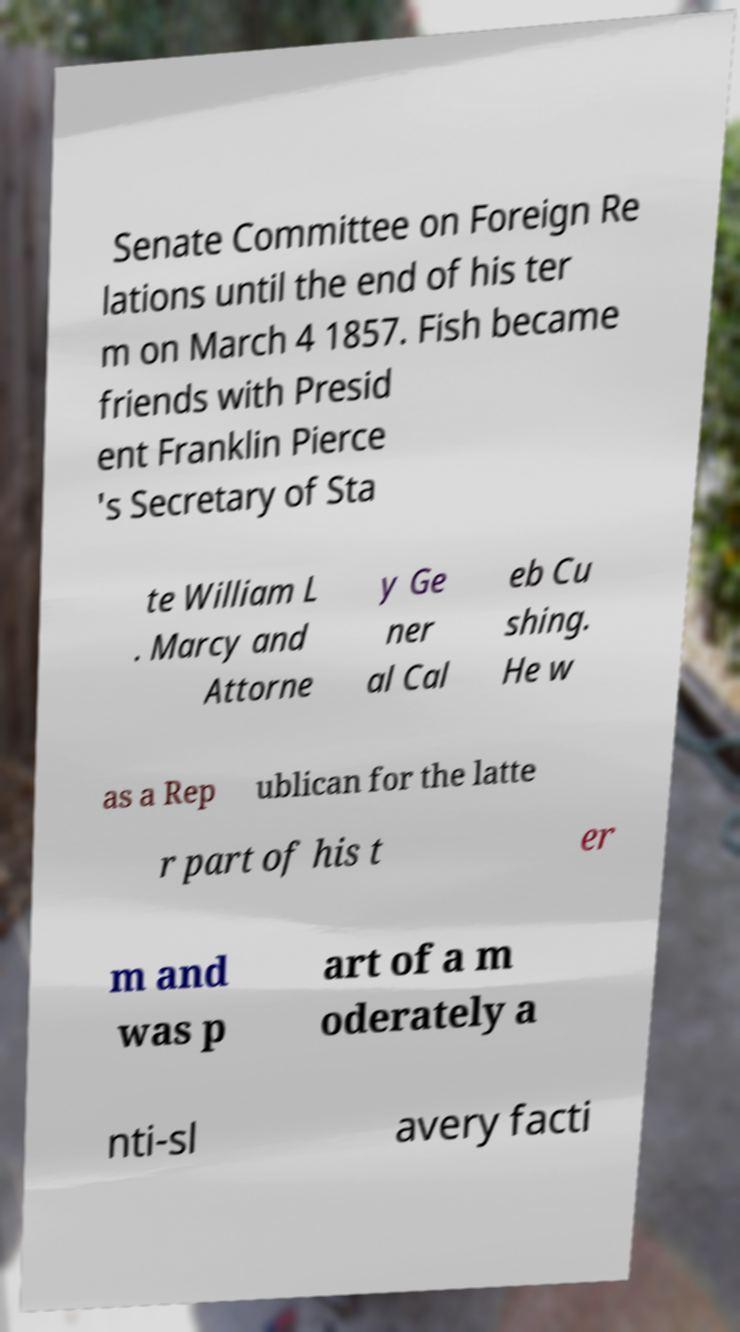I need the written content from this picture converted into text. Can you do that? Senate Committee on Foreign Re lations until the end of his ter m on March 4 1857. Fish became friends with Presid ent Franklin Pierce 's Secretary of Sta te William L . Marcy and Attorne y Ge ner al Cal eb Cu shing. He w as a Rep ublican for the latte r part of his t er m and was p art of a m oderately a nti-sl avery facti 